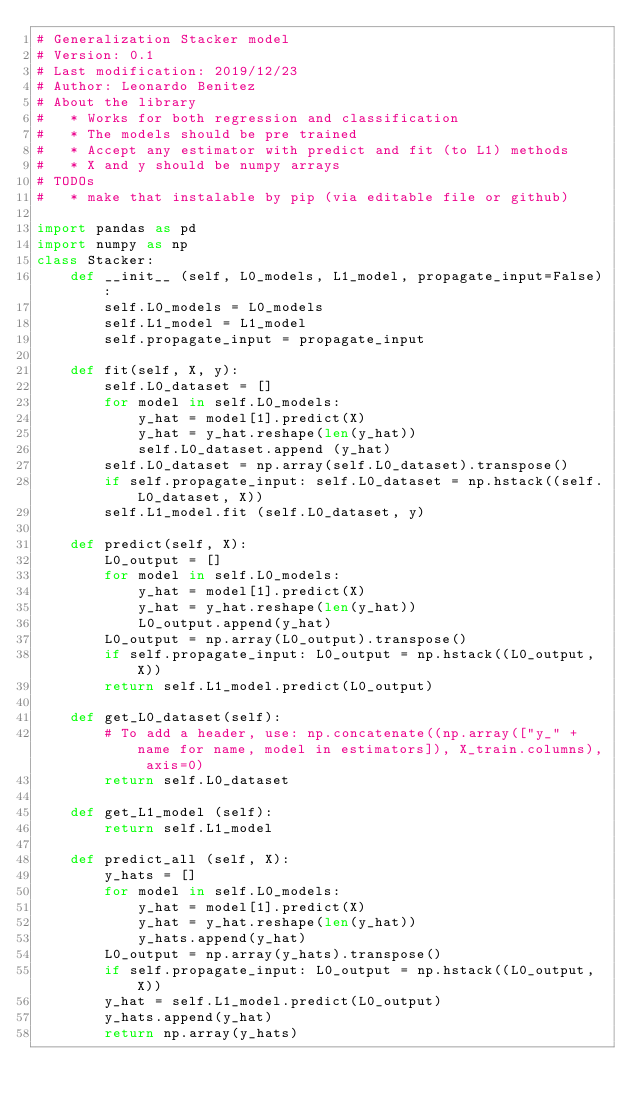<code> <loc_0><loc_0><loc_500><loc_500><_Python_># Generalization Stacker model
# Version: 0.1
# Last modification: 2019/12/23
# Author: Leonardo Benitez
# About the library
#   * Works for both regression and classification
#   * The models should be pre trained
#   * Accept any estimator with predict and fit (to L1) methods
#   * X and y should be numpy arrays
# TODOs
#   * make that instalable by pip (via editable file or github)

import pandas as pd
import numpy as np
class Stacker:
    def __init__ (self, L0_models, L1_model, propagate_input=False):
        self.L0_models = L0_models
        self.L1_model = L1_model
        self.propagate_input = propagate_input
    
    def fit(self, X, y):
        self.L0_dataset = []
        for model in self.L0_models:
            y_hat = model[1].predict(X)
            y_hat = y_hat.reshape(len(y_hat))
            self.L0_dataset.append (y_hat)
        self.L0_dataset = np.array(self.L0_dataset).transpose()
        if self.propagate_input: self.L0_dataset = np.hstack((self.L0_dataset, X))
        self.L1_model.fit (self.L0_dataset, y)
        
    def predict(self, X):
        L0_output = []
        for model in self.L0_models:
            y_hat = model[1].predict(X)
            y_hat = y_hat.reshape(len(y_hat))
            L0_output.append(y_hat)
        L0_output = np.array(L0_output).transpose()
        if self.propagate_input: L0_output = np.hstack((L0_output, X))
        return self.L1_model.predict(L0_output)
    
    def get_L0_dataset(self):
        # To add a header, use: np.concatenate((np.array(["y_" + name for name, model in estimators]), X_train.columns), axis=0)
        return self.L0_dataset
    
    def get_L1_model (self):
        return self.L1_model
    
    def predict_all (self, X):
        y_hats = []
        for model in self.L0_models:
            y_hat = model[1].predict(X)
            y_hat = y_hat.reshape(len(y_hat))
            y_hats.append(y_hat)  
        L0_output = np.array(y_hats).transpose()
        if self.propagate_input: L0_output = np.hstack((L0_output, X))
        y_hat = self.L1_model.predict(L0_output)
        y_hats.append(y_hat)  
        return np.array(y_hats)
</code> 